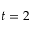Convert formula to latex. <formula><loc_0><loc_0><loc_500><loc_500>t = 2</formula> 